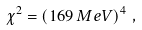<formula> <loc_0><loc_0><loc_500><loc_500>\chi ^ { 2 } = \left ( 1 6 9 \, M e V \right ) ^ { 4 } \, ,</formula> 